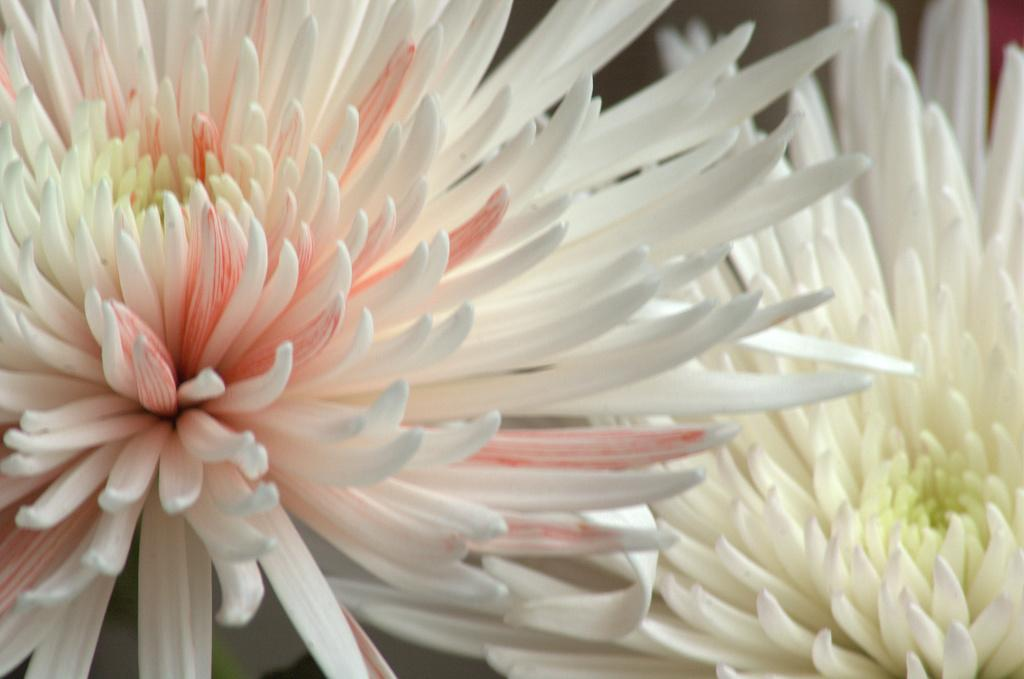How many flowers are present in the image? There are two flowers in the image. What color are the flowers? The flowers are white in color. What are the main features of the flowers? The flowers have petals. Did the flowers cause an earthquake in the image? There is no indication of an earthquake in the image, and flowers do not cause earthquakes. 